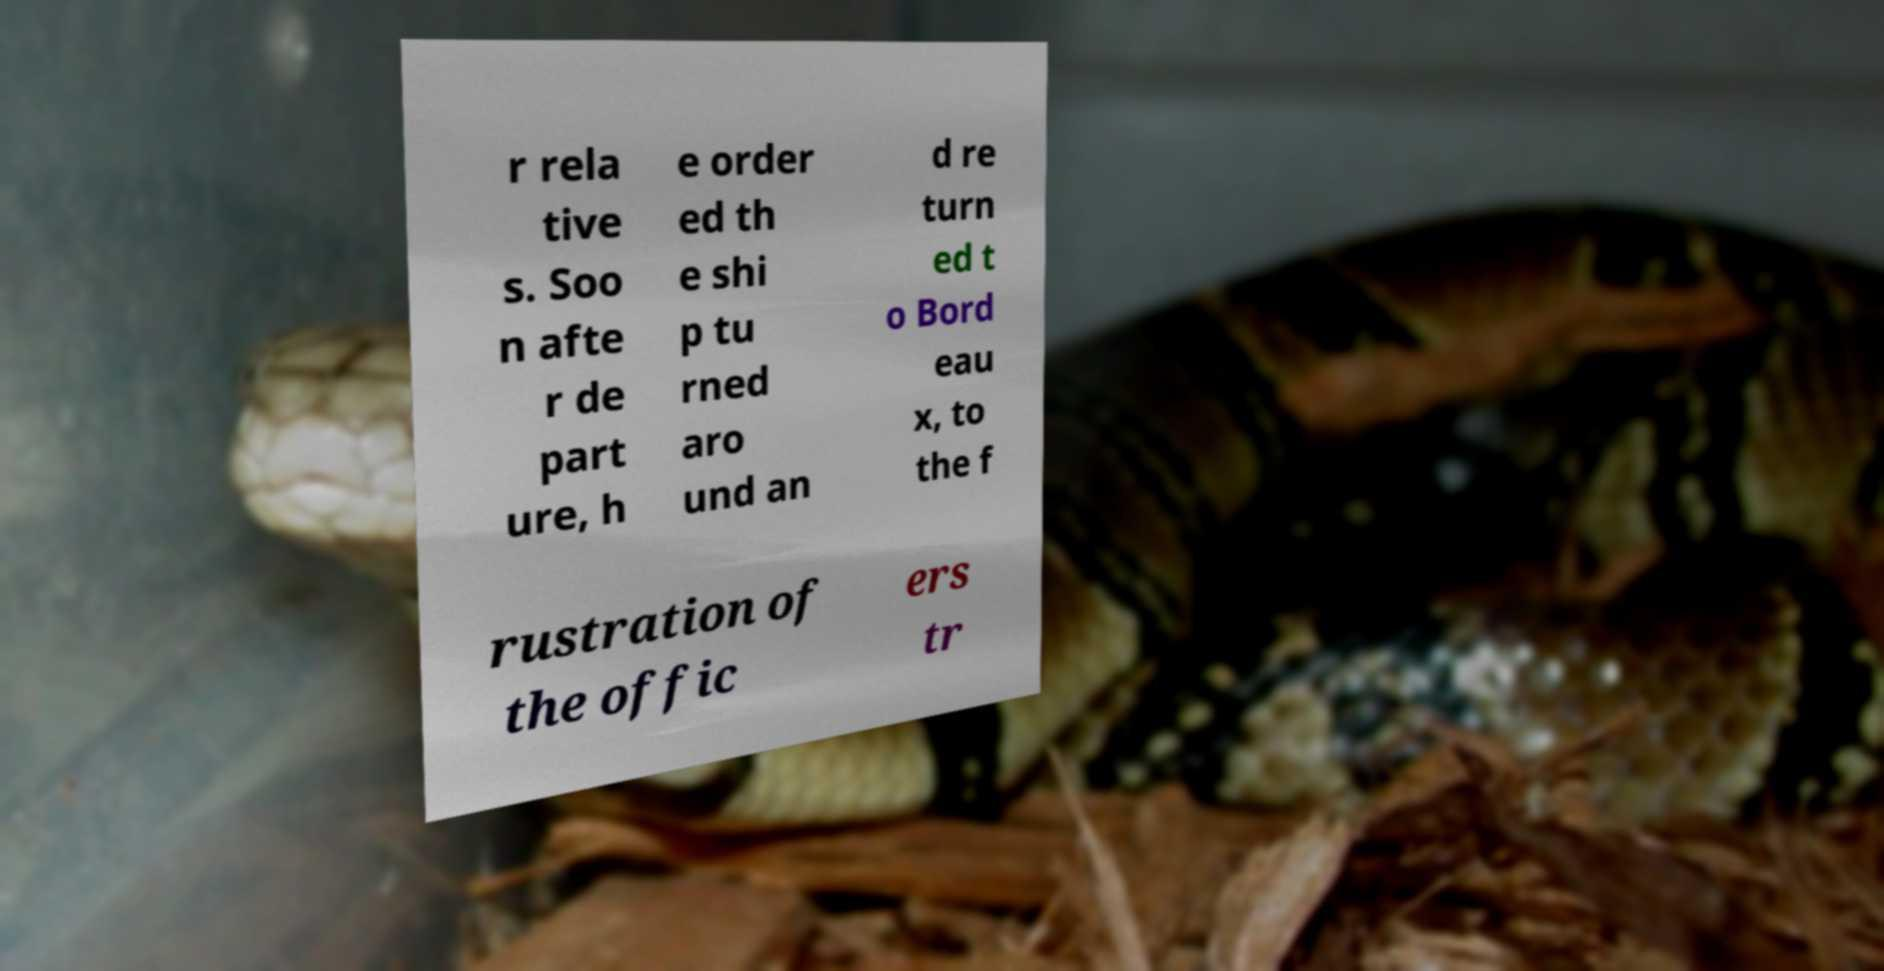Can you accurately transcribe the text from the provided image for me? r rela tive s. Soo n afte r de part ure, h e order ed th e shi p tu rned aro und an d re turn ed t o Bord eau x, to the f rustration of the offic ers tr 